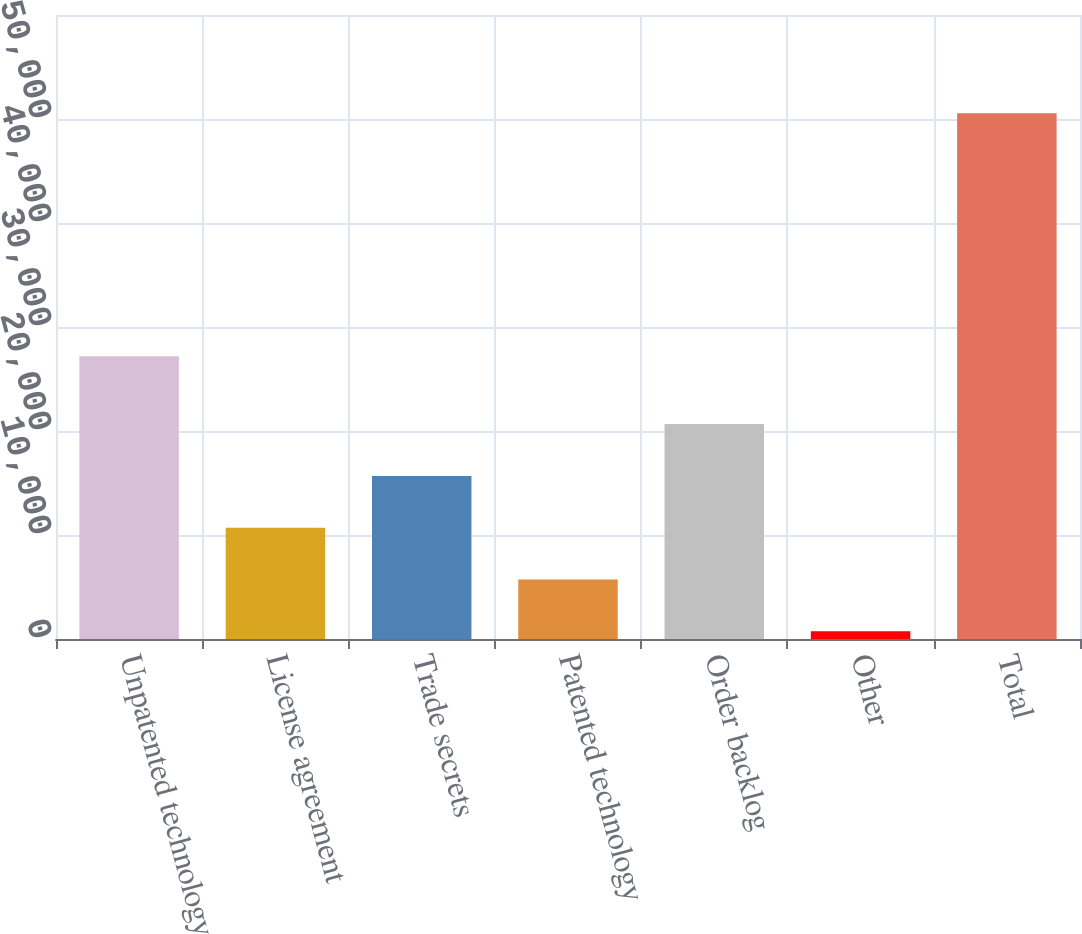Convert chart. <chart><loc_0><loc_0><loc_500><loc_500><bar_chart><fcel>Unpatented technology<fcel>License agreement<fcel>Trade secrets<fcel>Patented technology<fcel>Order backlog<fcel>Other<fcel>Total<nl><fcel>27180<fcel>10703.6<fcel>15684.4<fcel>5722.8<fcel>20665.2<fcel>742<fcel>50550<nl></chart> 